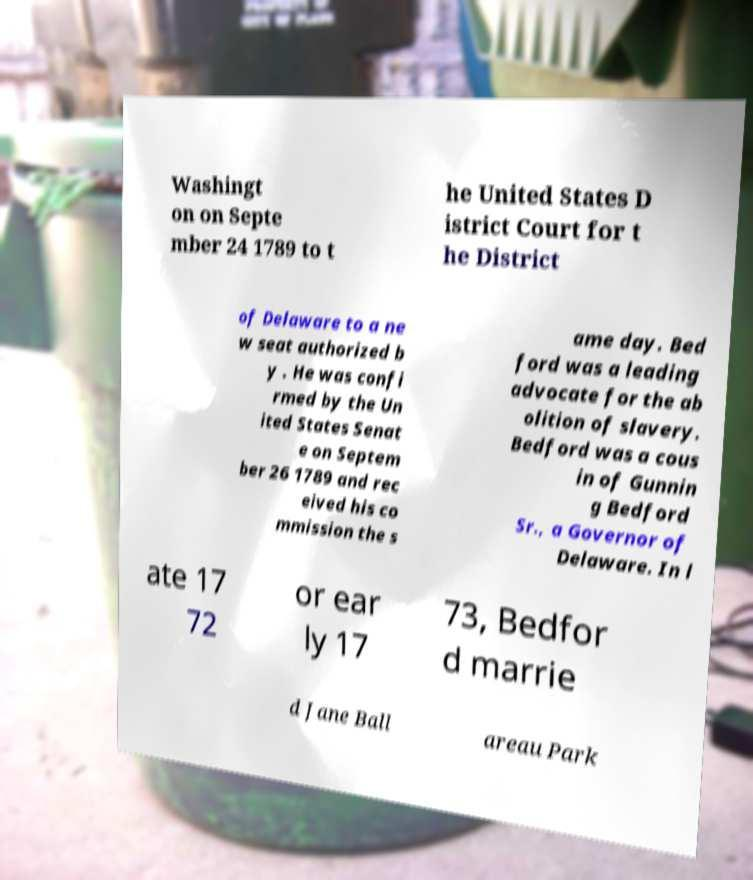Could you assist in decoding the text presented in this image and type it out clearly? Washingt on on Septe mber 24 1789 to t he United States D istrict Court for t he District of Delaware to a ne w seat authorized b y . He was confi rmed by the Un ited States Senat e on Septem ber 26 1789 and rec eived his co mmission the s ame day. Bed ford was a leading advocate for the ab olition of slavery. Bedford was a cous in of Gunnin g Bedford Sr., a Governor of Delaware. In l ate 17 72 or ear ly 17 73, Bedfor d marrie d Jane Ball areau Park 